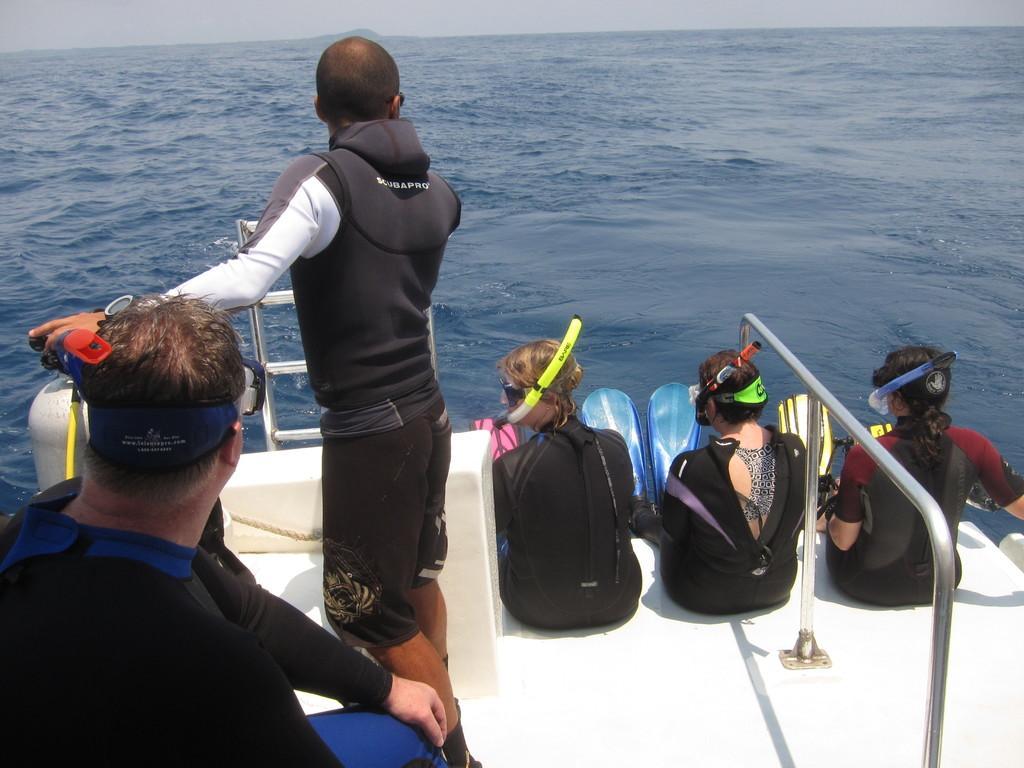In one or two sentences, can you explain what this image depicts? In this image there are people on the boat which is sailing on the surface of the water. Top of the image there is sky. Left side there is a person standing. He is wearing a jacket. 